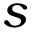<formula> <loc_0><loc_0><loc_500><loc_500>s</formula> 